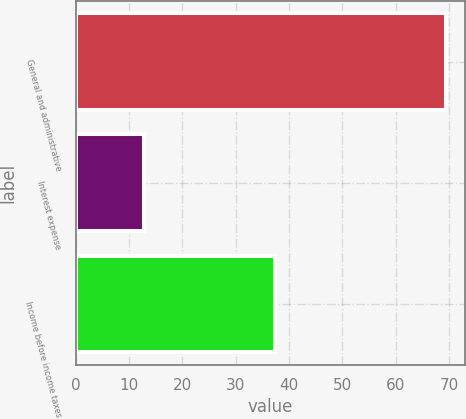Convert chart to OTSL. <chart><loc_0><loc_0><loc_500><loc_500><bar_chart><fcel>General and administrative<fcel>Interest expense<fcel>Income before income taxes<nl><fcel>69.5<fcel>12.8<fcel>37.3<nl></chart> 